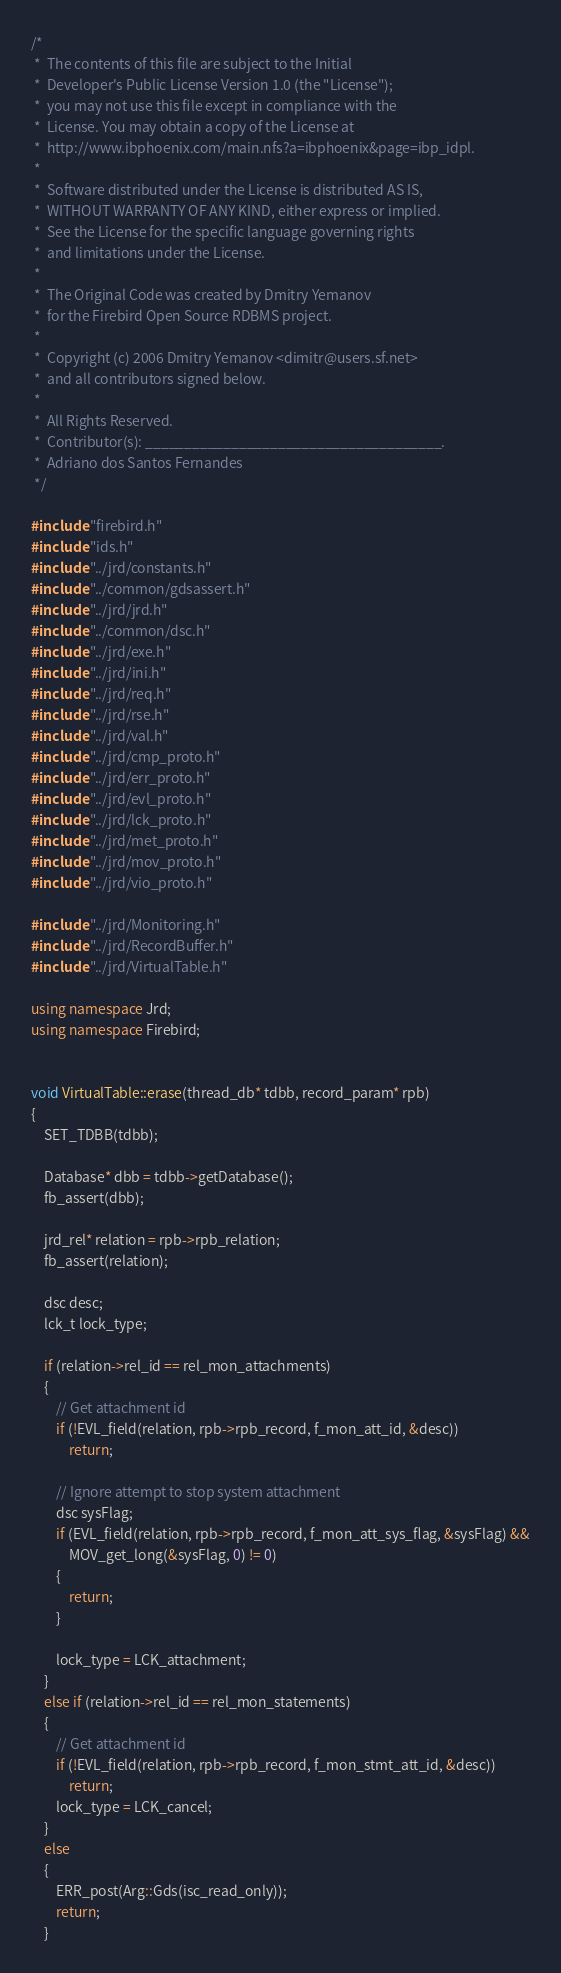<code> <loc_0><loc_0><loc_500><loc_500><_C++_>/*
 *  The contents of this file are subject to the Initial
 *  Developer's Public License Version 1.0 (the "License");
 *  you may not use this file except in compliance with the
 *  License. You may obtain a copy of the License at
 *  http://www.ibphoenix.com/main.nfs?a=ibphoenix&page=ibp_idpl.
 *
 *  Software distributed under the License is distributed AS IS,
 *  WITHOUT WARRANTY OF ANY KIND, either express or implied.
 *  See the License for the specific language governing rights
 *  and limitations under the License.
 *
 *  The Original Code was created by Dmitry Yemanov
 *  for the Firebird Open Source RDBMS project.
 *
 *  Copyright (c) 2006 Dmitry Yemanov <dimitr@users.sf.net>
 *  and all contributors signed below.
 *
 *  All Rights Reserved.
 *  Contributor(s): ______________________________________.
 *  Adriano dos Santos Fernandes
 */

#include "firebird.h"
#include "ids.h"
#include "../jrd/constants.h"
#include "../common/gdsassert.h"
#include "../jrd/jrd.h"
#include "../common/dsc.h"
#include "../jrd/exe.h"
#include "../jrd/ini.h"
#include "../jrd/req.h"
#include "../jrd/rse.h"
#include "../jrd/val.h"
#include "../jrd/cmp_proto.h"
#include "../jrd/err_proto.h"
#include "../jrd/evl_proto.h"
#include "../jrd/lck_proto.h"
#include "../jrd/met_proto.h"
#include "../jrd/mov_proto.h"
#include "../jrd/vio_proto.h"

#include "../jrd/Monitoring.h"
#include "../jrd/RecordBuffer.h"
#include "../jrd/VirtualTable.h"

using namespace Jrd;
using namespace Firebird;


void VirtualTable::erase(thread_db* tdbb, record_param* rpb)
{
	SET_TDBB(tdbb);

	Database* dbb = tdbb->getDatabase();
	fb_assert(dbb);

	jrd_rel* relation = rpb->rpb_relation;
	fb_assert(relation);

	dsc desc;
	lck_t lock_type;

	if (relation->rel_id == rel_mon_attachments)
	{
		// Get attachment id
		if (!EVL_field(relation, rpb->rpb_record, f_mon_att_id, &desc))
			return;

		// Ignore attempt to stop system attachment
		dsc sysFlag;
		if (EVL_field(relation, rpb->rpb_record, f_mon_att_sys_flag, &sysFlag) &&
			MOV_get_long(&sysFlag, 0) != 0)
		{
			return;
		}

		lock_type = LCK_attachment;
	}
	else if (relation->rel_id == rel_mon_statements)
	{
		// Get attachment id
		if (!EVL_field(relation, rpb->rpb_record, f_mon_stmt_att_id, &desc))
			return;
		lock_type = LCK_cancel;
	}
	else
	{
		ERR_post(Arg::Gds(isc_read_only));
		return;
	}
</code> 